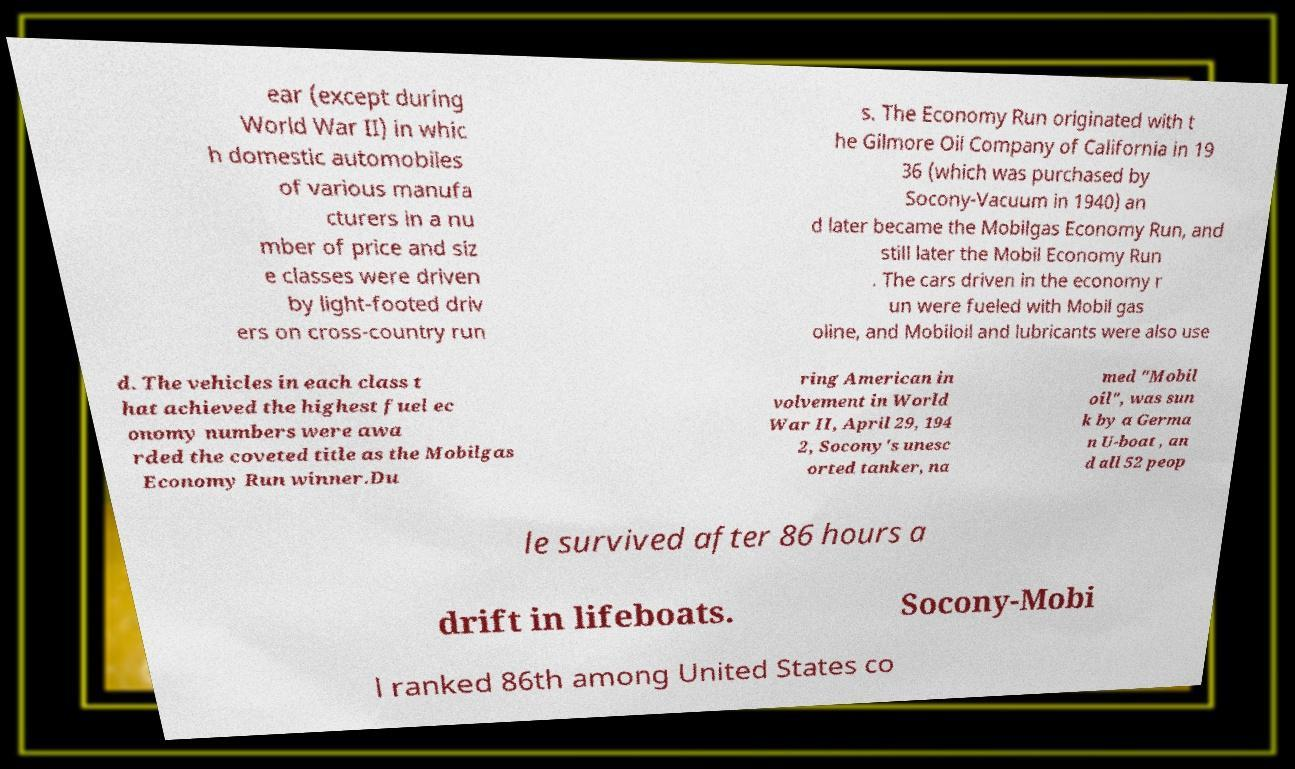For documentation purposes, I need the text within this image transcribed. Could you provide that? ear (except during World War II) in whic h domestic automobiles of various manufa cturers in a nu mber of price and siz e classes were driven by light-footed driv ers on cross-country run s. The Economy Run originated with t he Gilmore Oil Company of California in 19 36 (which was purchased by Socony-Vacuum in 1940) an d later became the Mobilgas Economy Run, and still later the Mobil Economy Run . The cars driven in the economy r un were fueled with Mobil gas oline, and Mobiloil and lubricants were also use d. The vehicles in each class t hat achieved the highest fuel ec onomy numbers were awa rded the coveted title as the Mobilgas Economy Run winner.Du ring American in volvement in World War II, April 29, 194 2, Socony's unesc orted tanker, na med "Mobil oil", was sun k by a Germa n U-boat , an d all 52 peop le survived after 86 hours a drift in lifeboats. Socony-Mobi l ranked 86th among United States co 